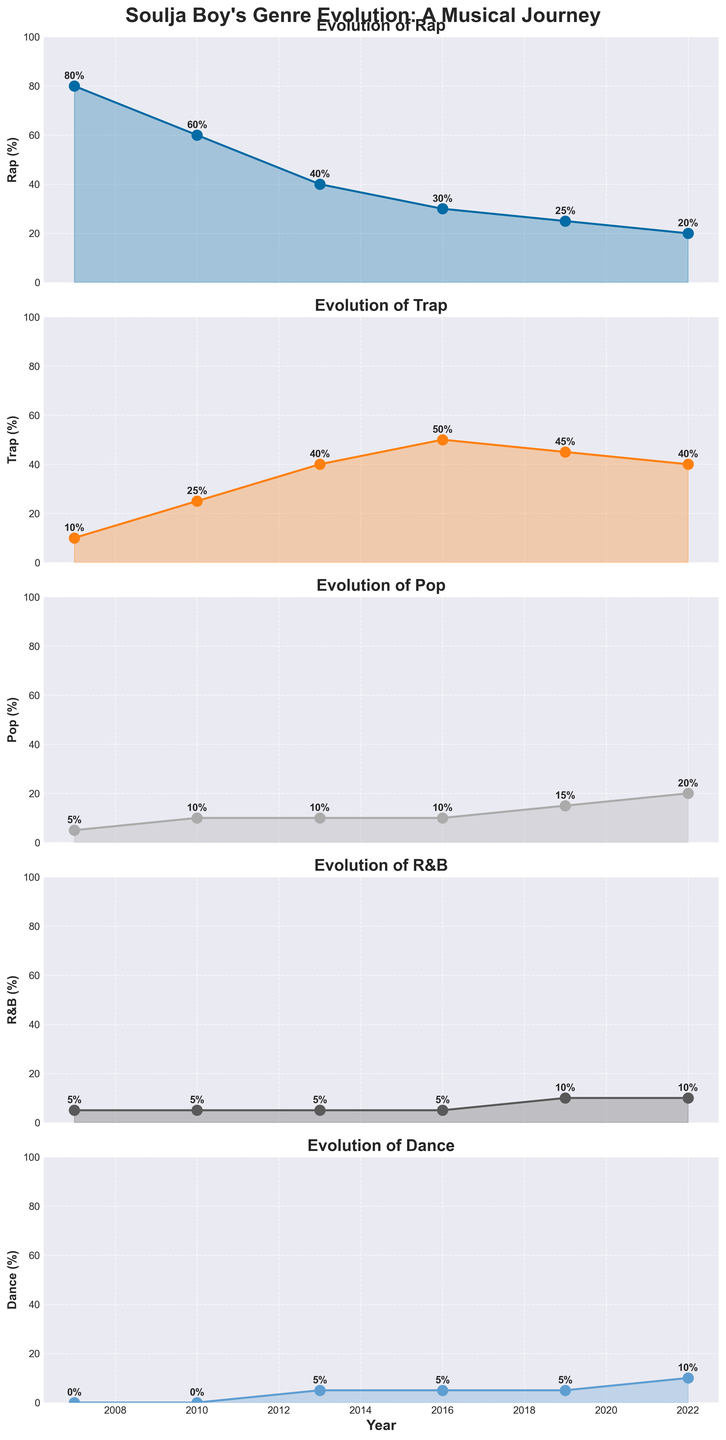What's the title of the entire figure? The title is usually located at the top of the figure and summarizes the purpose of the visual representation.
Answer: Soulja Boy's Genre Evolution: A Musical Journey What is the highest percentage of Rap reached over the years? To determine this, look at the Rap subplot and identify the maximum value on the y-axis.
Answer: 80% Which genre saw an increase in percentage from 2007 to 2022? Check each genre subplot and compare the values in 2007 and 2022, determining which genre showed an increase.
Answer: Pop, R&B, Dance In which year is the percentage of Trap music the highest? Look at the Trap subplot and find the year corresponding to the peak value on the y-axis.
Answer: 2016 How does the percentage of Pop music in 2010 compare to that in 2022? Inspect the Pop subplot and compare the y-values for the years 2010 and 2022. 2010 has a percentage of 10%, and 2022 has a percentage of 20%. Comparison indicates that 2022 has increased.
Answer: 2022 has increased Which genre showed the least experimentation in 2007? Analyze the percentages for all genres in 2007 and identify the one with the lowest value.
Answer: Dance What is the overall trend of R&B music from 2007 to 2022? Observe the R&B subplot and note whether the values increase, decrease, or remain consistent over the years.
Answer: Slightly increasing Compare the percentage of Dance music in 2013 and 2019. Which year had a higher percentage? Look at the Dance subplot and compare the y-values for the years 2013 and 2019.
Answer: 2013 and 2019 both had 5% During which year did Trap music surpass Rap music in percentage for the first time? Identify the year when the Trap subplot value first becomes higher than the corresponding value in the Rap subplot.
Answer: 2013 